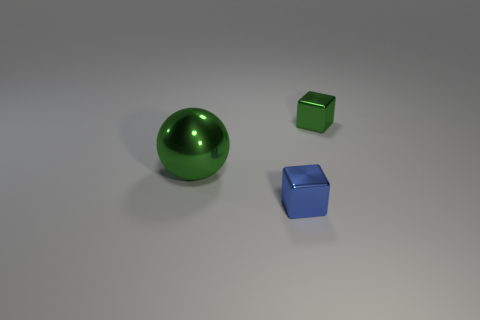Add 3 purple metallic cubes. How many objects exist? 6 Subtract all spheres. How many objects are left? 2 Subtract 0 gray cylinders. How many objects are left? 3 Subtract all large green metal spheres. Subtract all metallic cylinders. How many objects are left? 2 Add 3 small objects. How many small objects are left? 5 Add 1 small blue cubes. How many small blue cubes exist? 2 